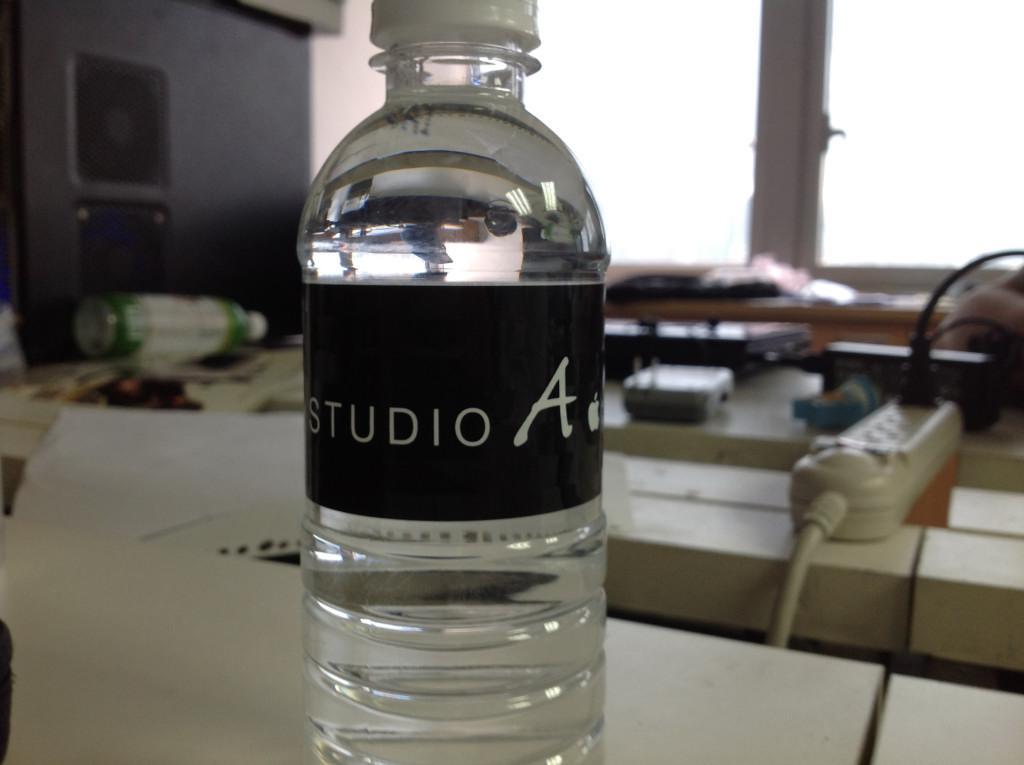What type of water is that?
Your answer should be very brief. Studio a. Whose brand is featured?
Make the answer very short. Studio a. 